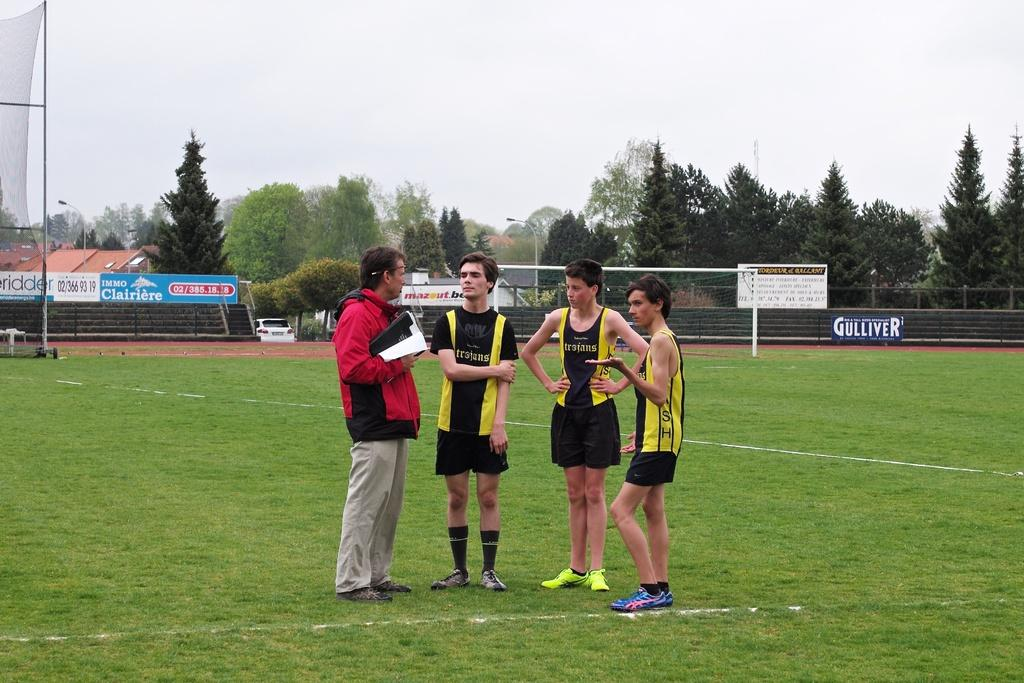<image>
Render a clear and concise summary of the photo. Members of the Trojans stand on the field and speak with their coach. 